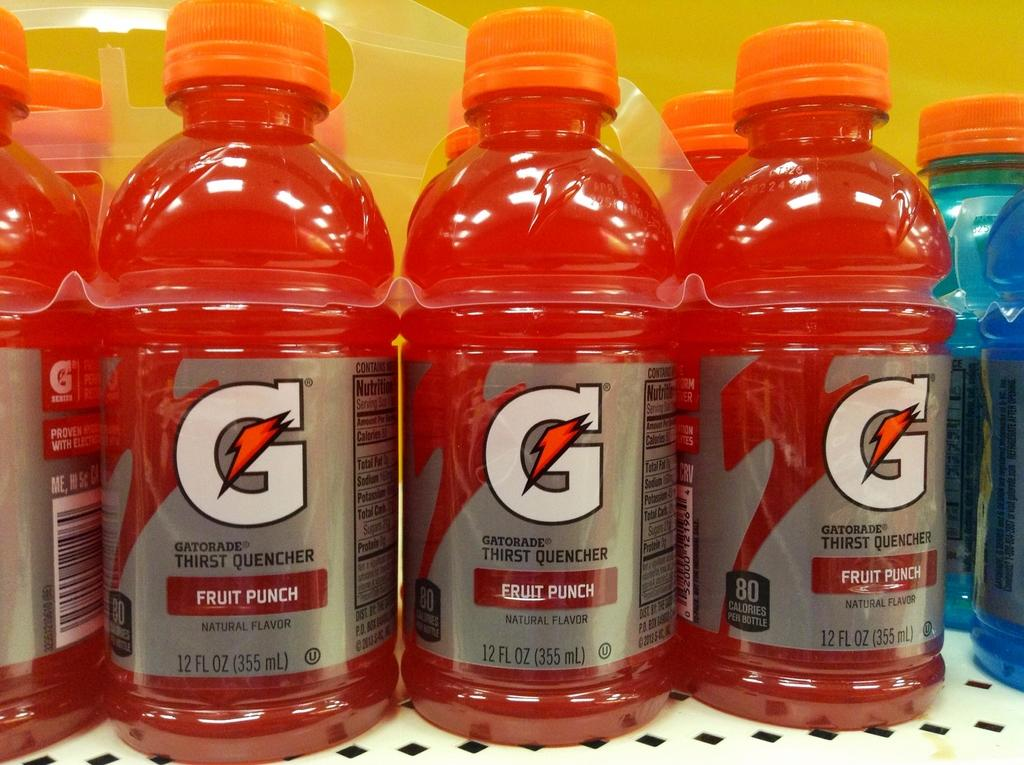Provide a one-sentence caption for the provided image. A multi-pack of Fruit Punch Gatorade rests on a shelf. 